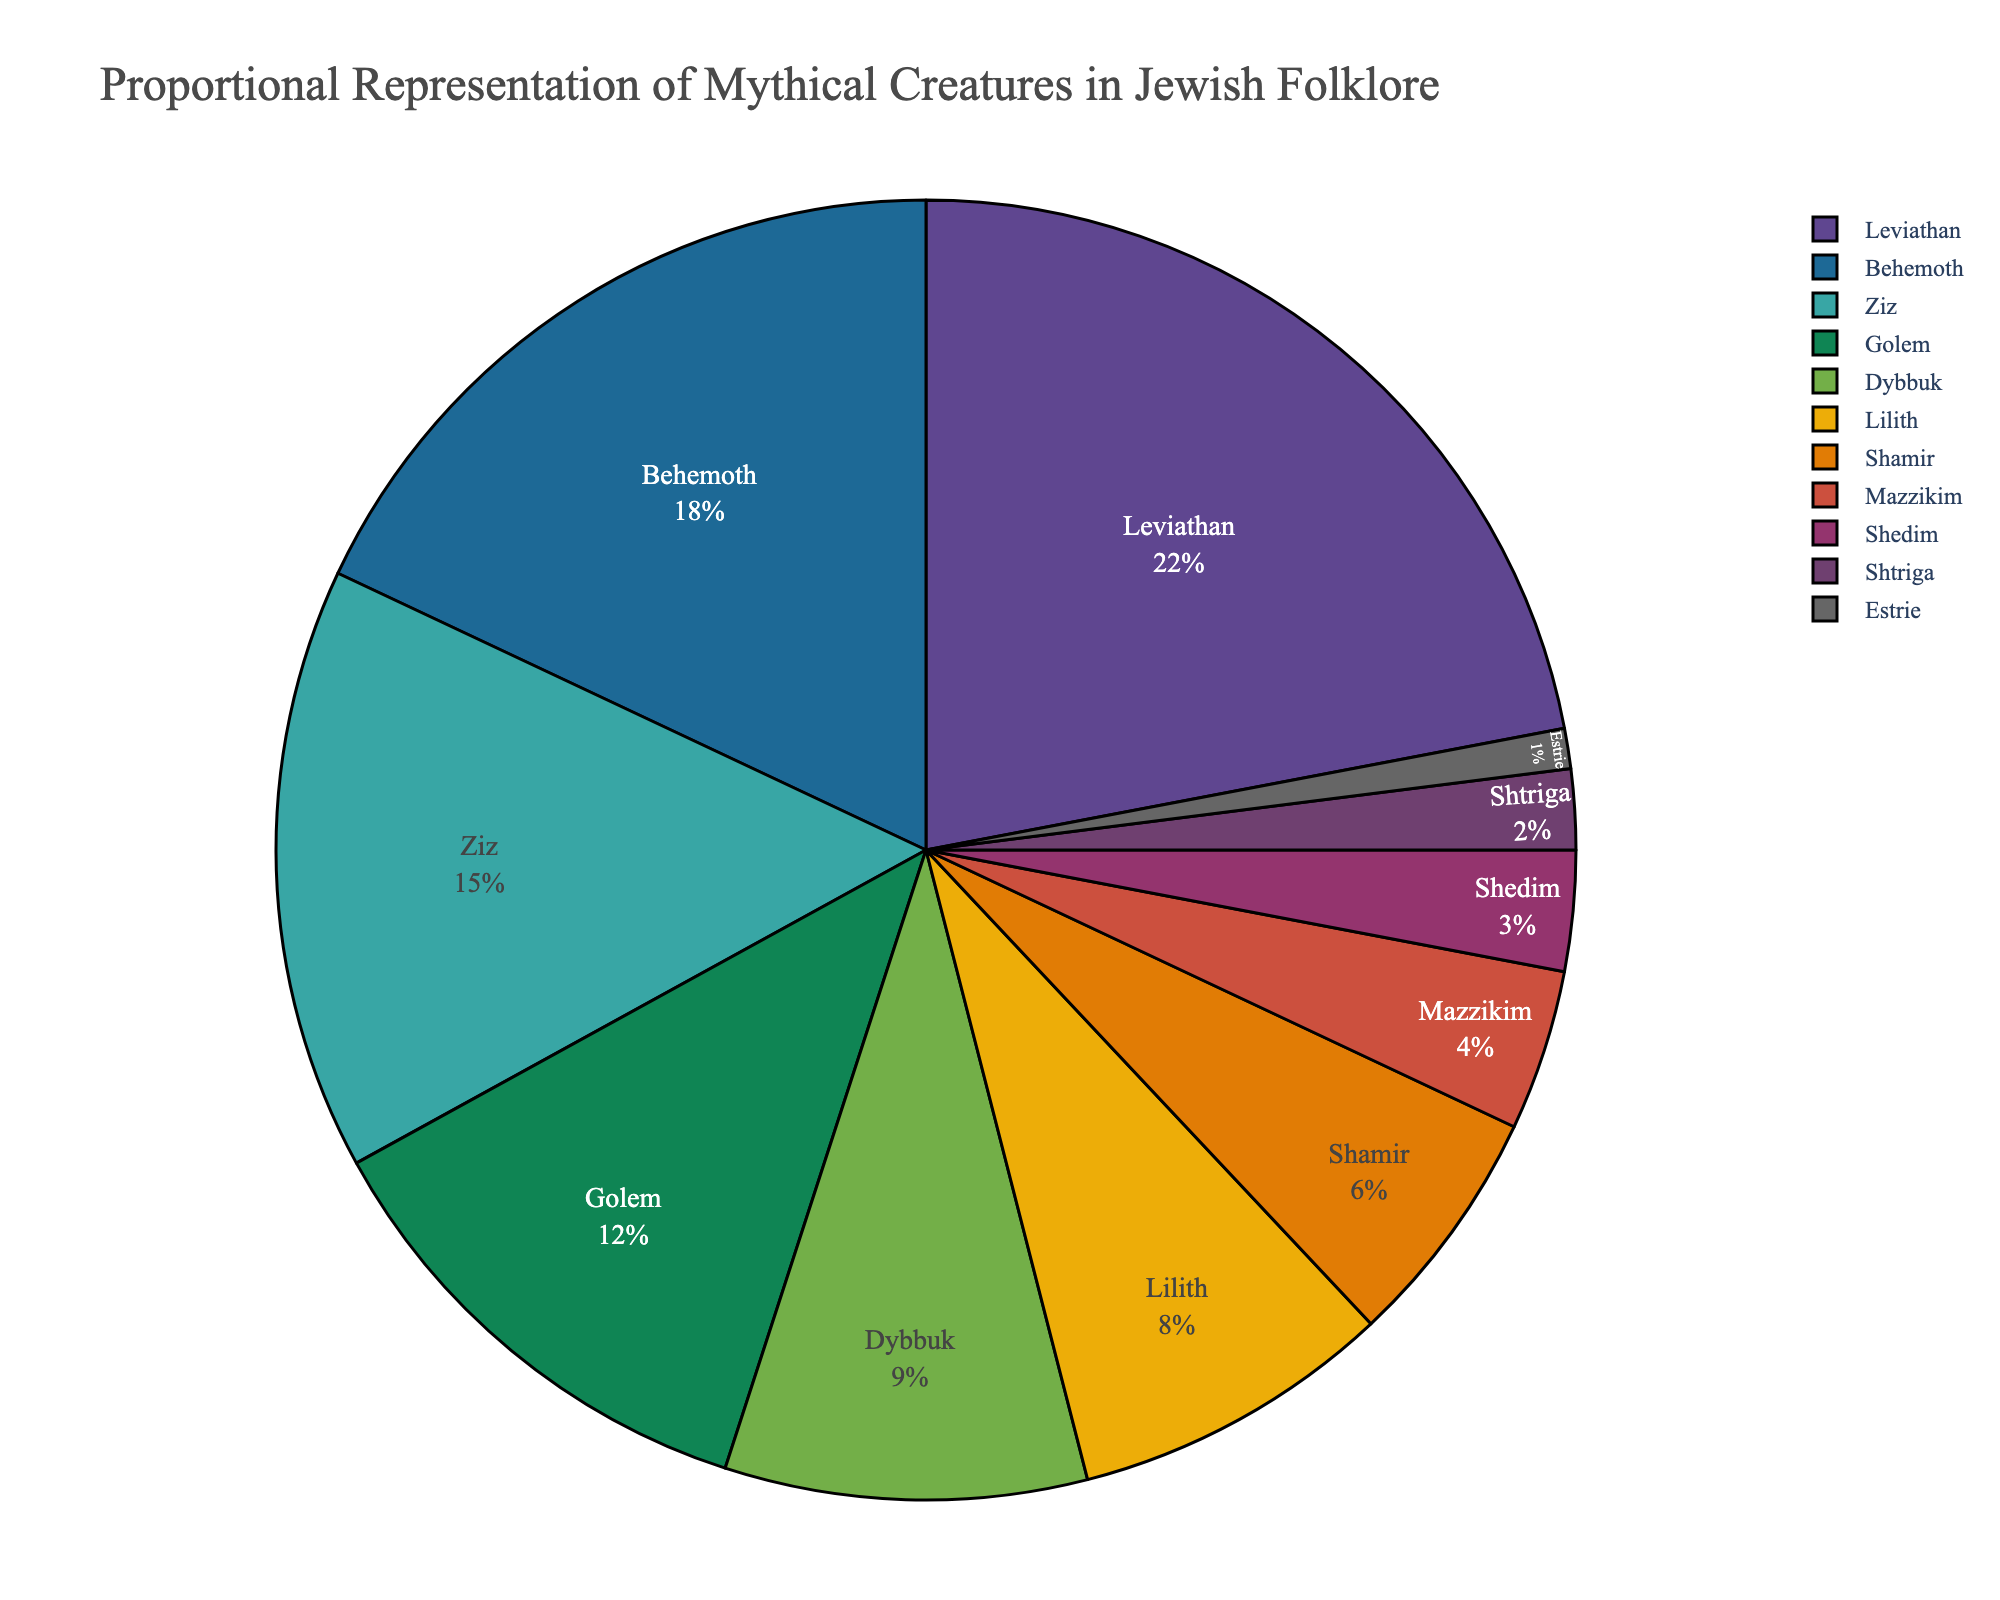Which mythical creature has the highest proportional representation? To identify the creature with the highest representation, look for the largest slice in the pie chart. In this case, the Leviathan has the largest section, indicating it has the highest proportion.
Answer: Leviathan How much larger is the representation of Leviathan compared to Behemoth? To find the difference in representation between two creatures, subtract the percentage of Behemoth from that of Leviathan. The Leviathan has 22%, and Behemoth has 18%, so 22% - 18% = 4%.
Answer: 4% Which creatures have a proportional representation of less than 5%? Scan the pie chart for all slices that represent less than 5% of the total. These are Mazzikim (4%), Shedim (3%), Shtriga (2%), and Estrie (1%).
Answer: Mazzikim, Shedim, Shtriga, Estrie What is the combined proportional representation of Leviathan, Behemoth, and Ziz? Add the percentages of Leviathan (22%), Behemoth (18%), and Ziz (15%). So, 22% + 18% + 15% = 55%.
Answer: 55% How does the representation of Golem compare to Dybbuk? Compare the percentages of Golem (12%) and Dybbuk (9%). Golem has a higher representation by 3%. So, 12% - 9% = 3%.
Answer: Golem has 3% more representation than Dybbuk Which creature's slice appears the smallest on the chart? Identify the smallest slice on the pie chart, which represents the creature with the least representation. Estrie has the smallest slice at 1%.
Answer: Estrie What is the total percentage representation of creatures with 8% or more? Add the percentages of creatures that have 8% or more: Leviathan (22%), Behemoth (18%), Ziz (15%), Golem (12%), Dybbuk (9%), and Lilith (8%). So, 22% + 18% + 15% + 12% + 9% + 8% = 84%.
Answer: 84% How many creatures have a representation between 5% and 10%? Count the number of creatures whose representation falls between 5% and 10%. These are Shamir (6%) and Dybbuk (9%).
Answer: 2 creatures 